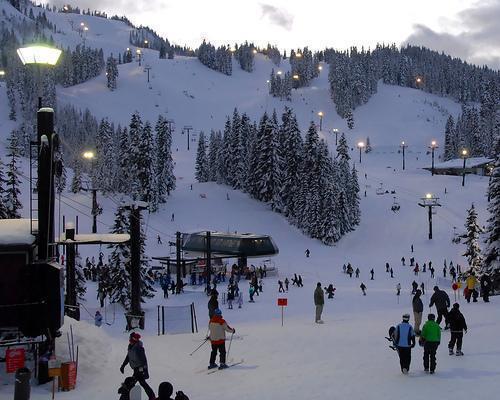What does this scene look most like?
From the following set of four choices, select the accurate answer to respond to the question.
Options: Winter wonderland, maypole dance, desert, seaside villa. Winter wonderland. 